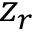<formula> <loc_0><loc_0><loc_500><loc_500>z _ { r }</formula> 